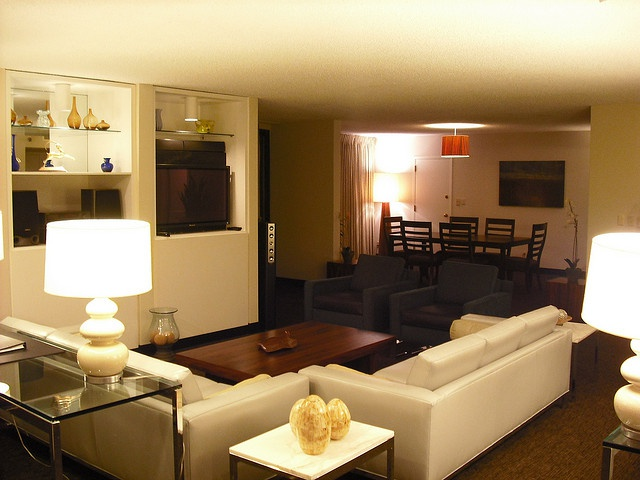Describe the objects in this image and their specific colors. I can see couch in tan tones, couch in tan and maroon tones, chair in tan, black, maroon, and gray tones, tv in tan, black, maroon, and olive tones, and dining table in tan, black, maroon, and brown tones in this image. 